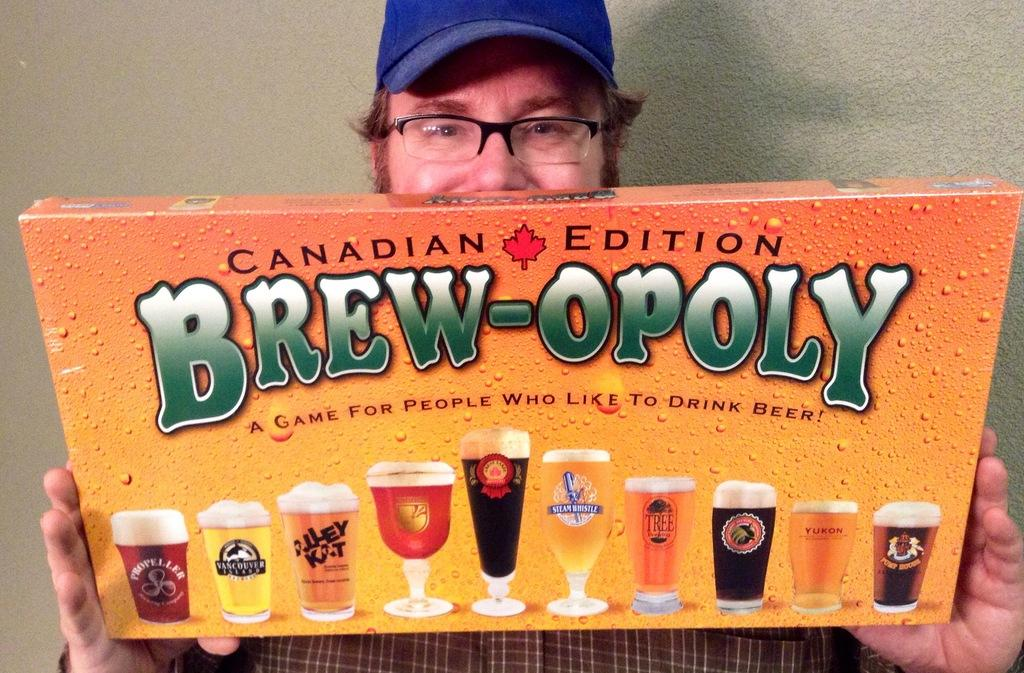<image>
Summarize the visual content of the image. A man holds a Canadian Edition Brew-Opoly game in his hands. 